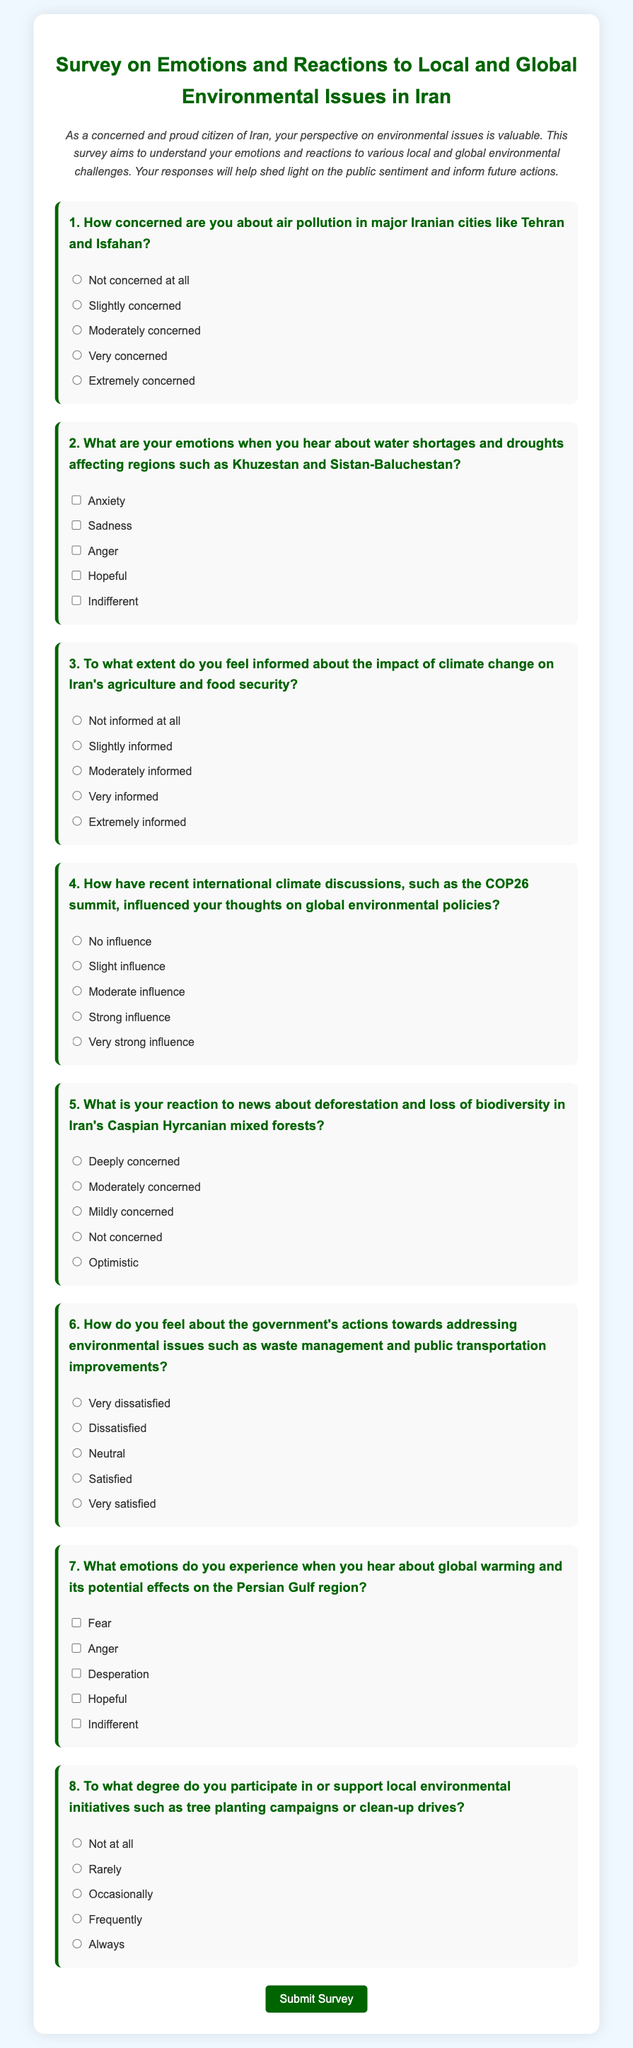What is the title of the survey? The title of the survey is at the top of the document and states the focus of the survey regarding emotions and reactions to environmental issues.
Answer: Survey on Emotions and Reactions to Local and Global Environmental Issues in Iran How many questions are in the survey? The number of questions can be counted directly from the document as it is listed sequentially.
Answer: Eight What does question two ask about? Question two addresses the emotions individuals experience related to specific environmental issues.
Answer: Water shortages and droughts What color is the survey container background? The background color of the survey container can be identified by examining the document's style attributes.
Answer: White Which city is mentioned in relation to air pollution concerns? One of the cities referenced specifically for air pollution is named in the first survey question.
Answer: Tehran What kind of feelings does question seven inquire about? Question seven asks about various emotions in response to global environmental issues affecting a specific region.
Answer: Global warming effects on the Persian Gulf region What response options are available for question six? The response options can be identified as ratings reflecting satisfaction towards government actions on environmental issues.
Answer: Very dissatisfied, Dissatisfied, Neutral, Satisfied, Very satisfied To what degree does question eight ask about participation in local initiatives? Question eight specifically addresses the frequency of participation in environmental initiatives local to the area.
Answer: Frequency of participation 